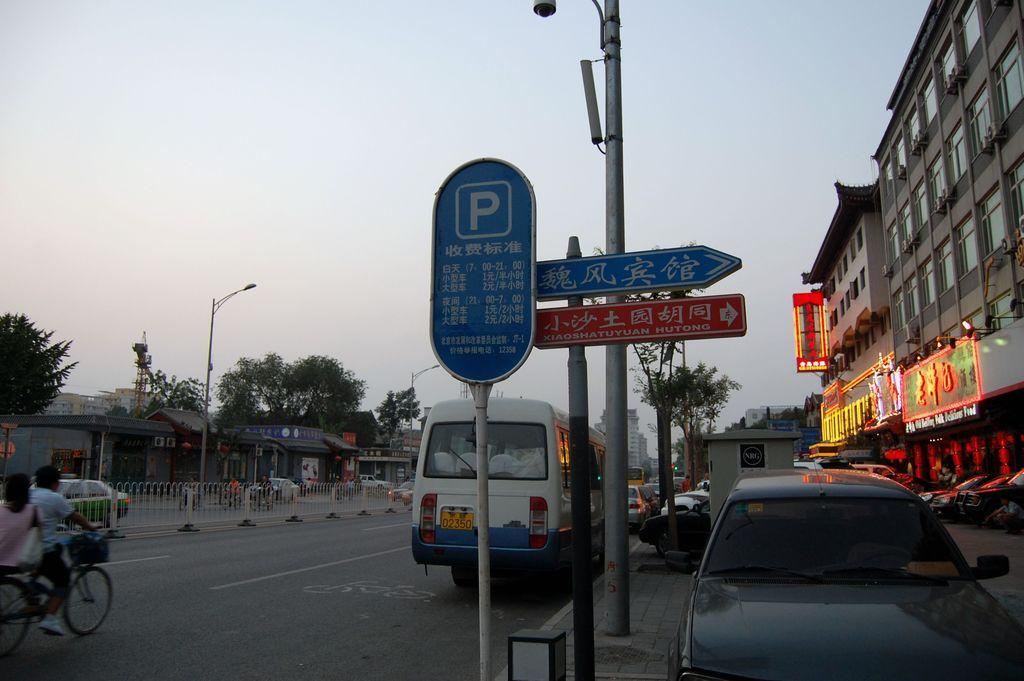What types of objects can be seen in the image? There are vehicles, poles, boards, a fence, trees, and buildings in the image. What activity are two persons engaged in? Two persons are riding a bicycle on the road. What can be seen in the background of the image? The sky is visible in the background of the image. What shape is the rake that is being used by the person in the image? There is no rake present in the image. What type of paper is being used by the person in the image? There is no person using paper in the image. 